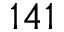Convert formula to latex. <formula><loc_0><loc_0><loc_500><loc_500>1 4 1</formula> 